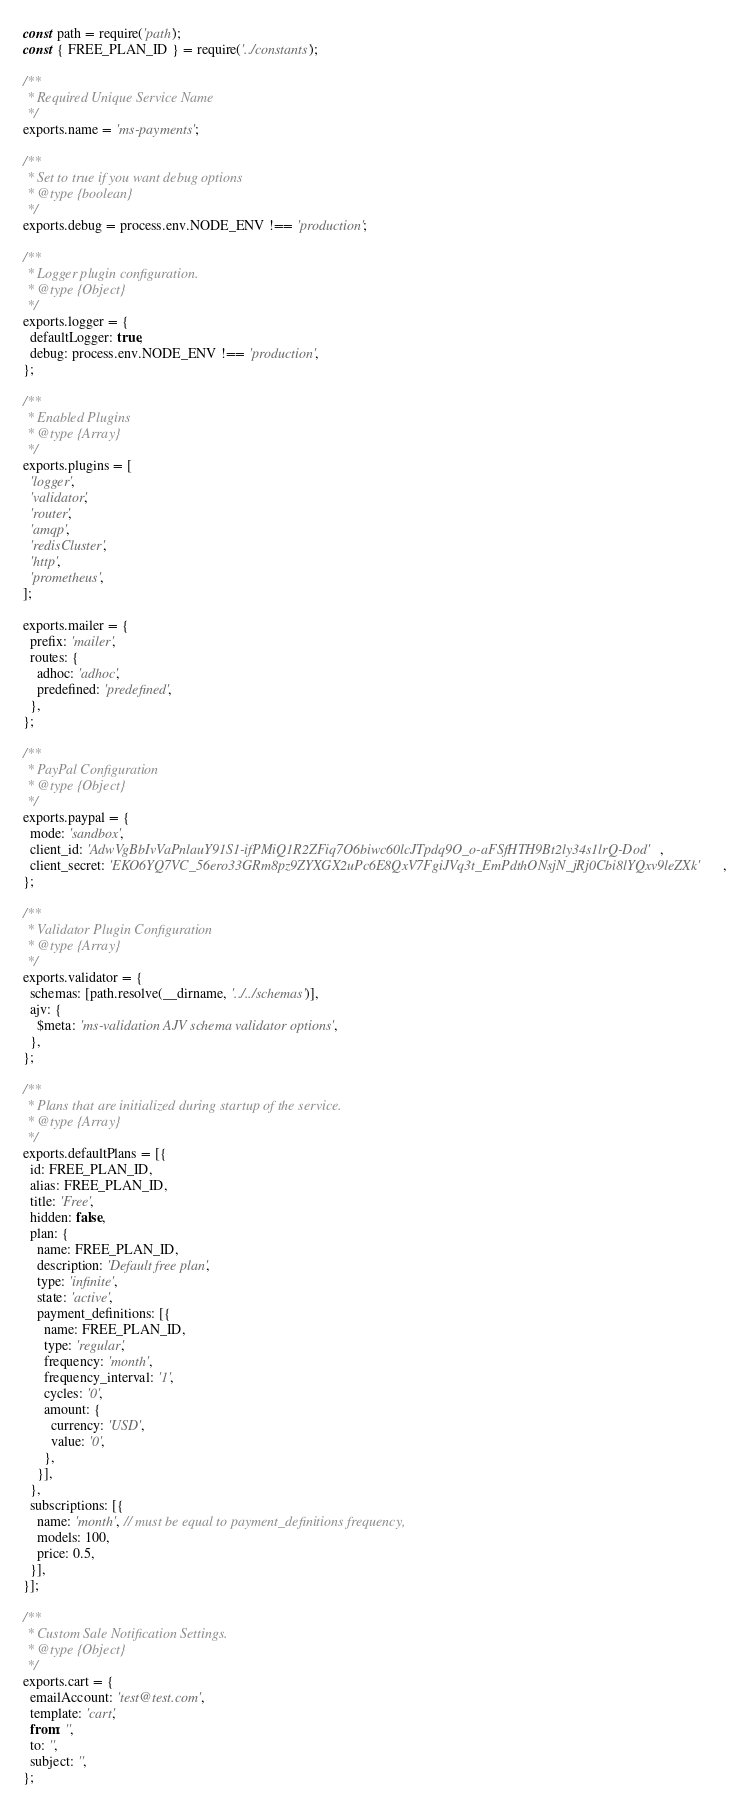<code> <loc_0><loc_0><loc_500><loc_500><_JavaScript_>const path = require('path');
const { FREE_PLAN_ID } = require('../constants');

/**
 * Required Unique Service Name
 */
exports.name = 'ms-payments';

/**
 * Set to true if you want debug options
 * @type {boolean}
 */
exports.debug = process.env.NODE_ENV !== 'production';

/**
 * Logger plugin configuration.
 * @type {Object}
 */
exports.logger = {
  defaultLogger: true,
  debug: process.env.NODE_ENV !== 'production',
};

/**
 * Enabled Plugins
 * @type {Array}
 */
exports.plugins = [
  'logger',
  'validator',
  'router',
  'amqp',
  'redisCluster',
  'http',
  'prometheus',
];

exports.mailer = {
  prefix: 'mailer',
  routes: {
    adhoc: 'adhoc',
    predefined: 'predefined',
  },
};

/**
 * PayPal Configuration
 * @type {Object}
 */
exports.paypal = {
  mode: 'sandbox',
  client_id: 'AdwVgBbIvVaPnlauY91S1-ifPMiQ1R2ZFiq7O6biwc60lcJTpdq9O_o-aFSfHTH9Bt2ly34s1lrQ-Dod',
  client_secret: 'EKO6YQ7VC_56ero33GRm8pz9ZYXGX2uPc6E8QxV7FgiJVq3t_EmPdthONsjN_jRj0Cbi8lYQxv9leZXk',
};

/**
 * Validator Plugin Configuration
 * @type {Array}
 */
exports.validator = {
  schemas: [path.resolve(__dirname, '../../schemas')],
  ajv: {
    $meta: 'ms-validation AJV schema validator options',
  },
};

/**
 * Plans that are initialized during startup of the service.
 * @type {Array}
 */
exports.defaultPlans = [{
  id: FREE_PLAN_ID,
  alias: FREE_PLAN_ID,
  title: 'Free',
  hidden: false,
  plan: {
    name: FREE_PLAN_ID,
    description: 'Default free plan',
    type: 'infinite',
    state: 'active',
    payment_definitions: [{
      name: FREE_PLAN_ID,
      type: 'regular',
      frequency: 'month',
      frequency_interval: '1',
      cycles: '0',
      amount: {
        currency: 'USD',
        value: '0',
      },
    }],
  },
  subscriptions: [{
    name: 'month', // must be equal to payment_definitions frequency,
    models: 100,
    price: 0.5,
  }],
}];

/**
 * Custom Sale Notification Settings.
 * @type {Object}
 */
exports.cart = {
  emailAccount: 'test@test.com',
  template: 'cart',
  from: '',
  to: '',
  subject: '',
};
</code> 